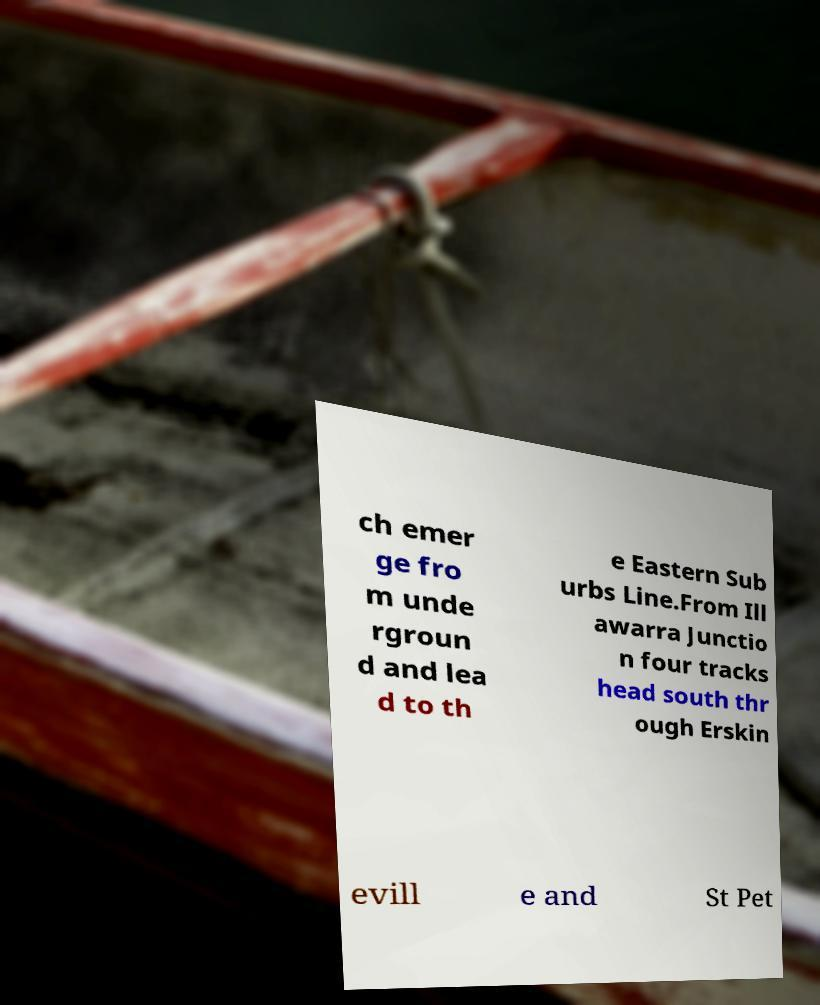Please identify and transcribe the text found in this image. ch emer ge fro m unde rgroun d and lea d to th e Eastern Sub urbs Line.From Ill awarra Junctio n four tracks head south thr ough Erskin evill e and St Pet 